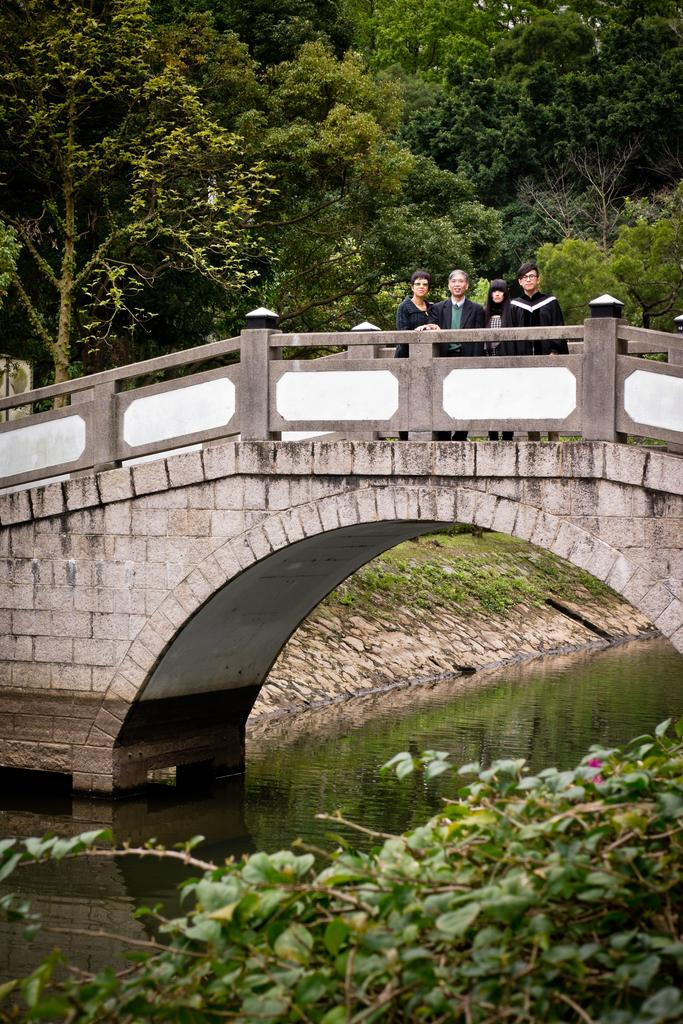What is happening on the bridge in the image? There are people on the bridge in the image. What can be seen below the bridge? There is water visible in the image. What type of vegetation is present in the image? There are plants in the image. What is visible in the background of the image? There are trees in the background of the image. Can you see a man using a quill to write on the bridge in the image? There is no man using a quill to write on the bridge in the image. What type of animal might fall from the trees in the background of the image? There is no animal present in the image, so it is not possible to determine what type of animal might fall from the trees. 